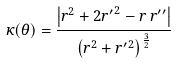Convert formula to latex. <formula><loc_0><loc_0><loc_500><loc_500>\kappa ( \theta ) = { \frac { \left | r ^ { 2 } + 2 { r ^ { \prime } } ^ { 2 } - r \, r ^ { \prime \prime } \right | } { \left ( r ^ { 2 } + { r ^ { \prime } } ^ { 2 } \right ) ^ { \frac { 3 } { 2 } } } }</formula> 